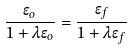<formula> <loc_0><loc_0><loc_500><loc_500>\frac { \epsilon _ { o } } { 1 + \lambda \epsilon _ { o } } = \frac { \epsilon _ { f } } { 1 + \lambda \epsilon _ { f } }</formula> 